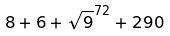<formula> <loc_0><loc_0><loc_500><loc_500>8 + 6 + \sqrt { 9 } ^ { 7 2 } + 2 9 0</formula> 